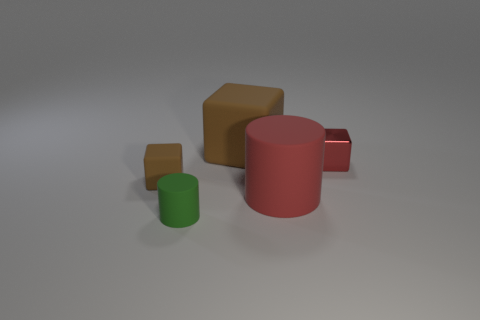There is a matte cylinder that is in front of the large red matte cylinder; what color is it? The matte cylinder situated in front of the large red matte cylinder is green in color. The green and red cylinders present a contrasting pair in this composition of geometric shapes. 